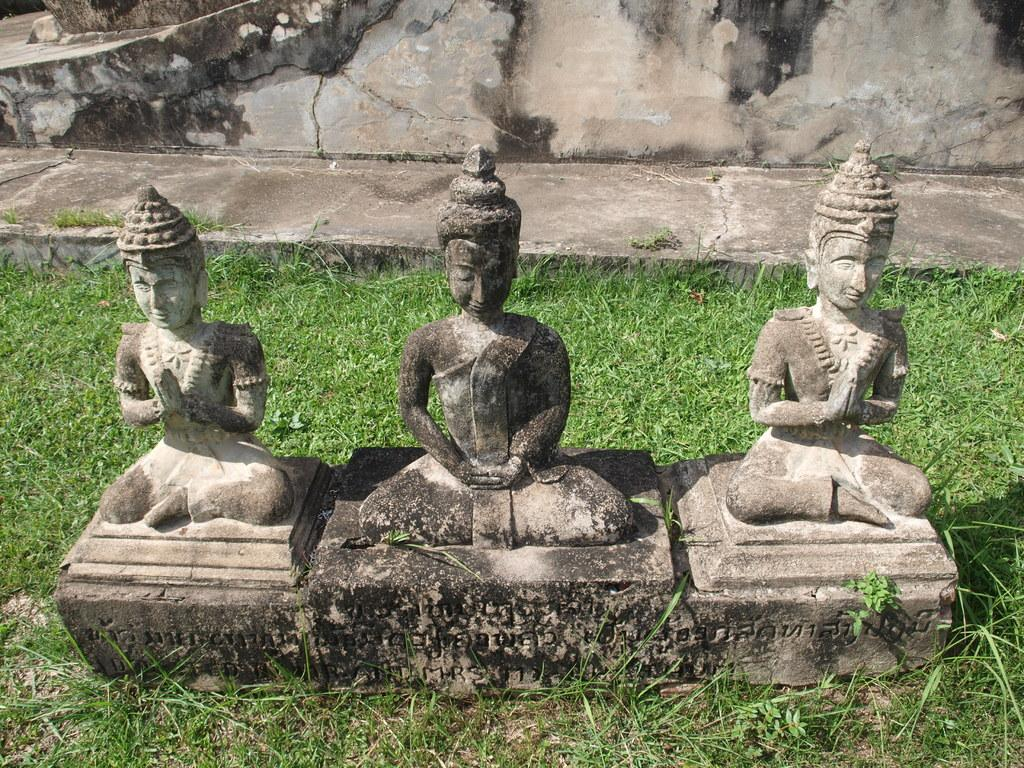How many statues are present in the image? There are three statues in the image. What is the landscape surrounding the statues? There is grass surrounding the statues. What type of brake system can be seen on the airplane in the image? There is no airplane present in the image, so there is no brake system to observe. 